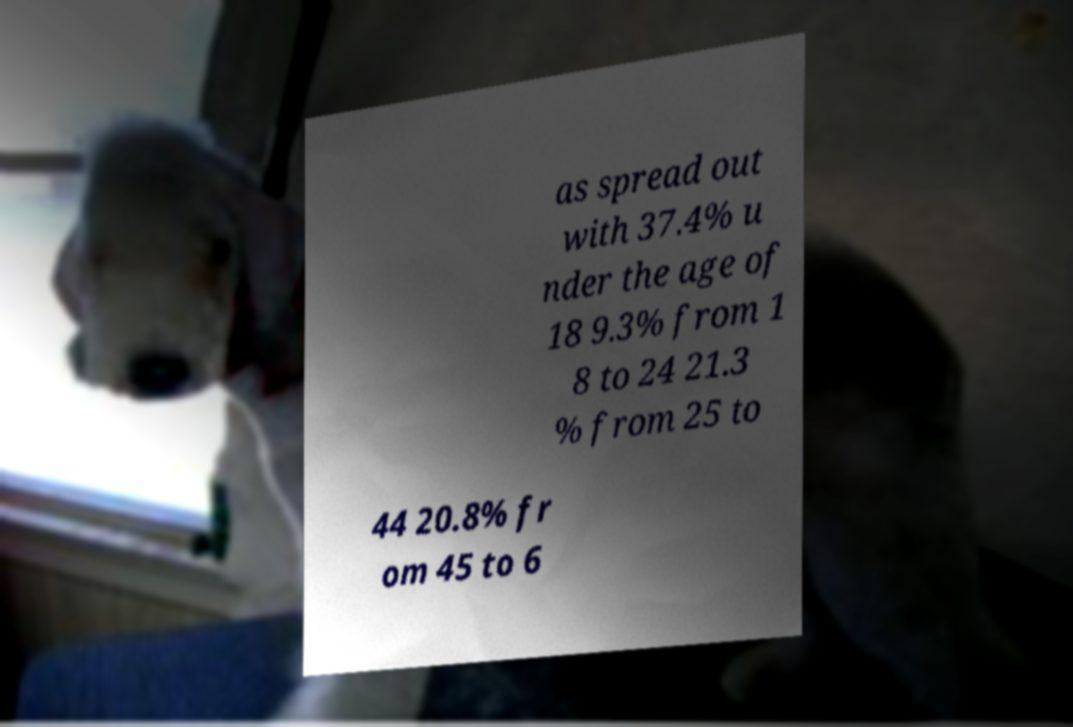Can you accurately transcribe the text from the provided image for me? as spread out with 37.4% u nder the age of 18 9.3% from 1 8 to 24 21.3 % from 25 to 44 20.8% fr om 45 to 6 